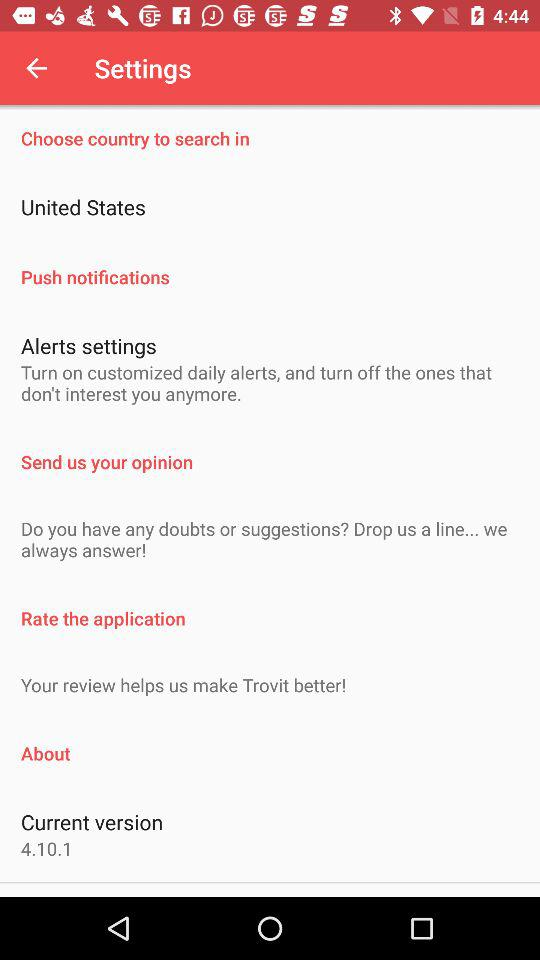Which country is chosen? The chosen country is the United States. 